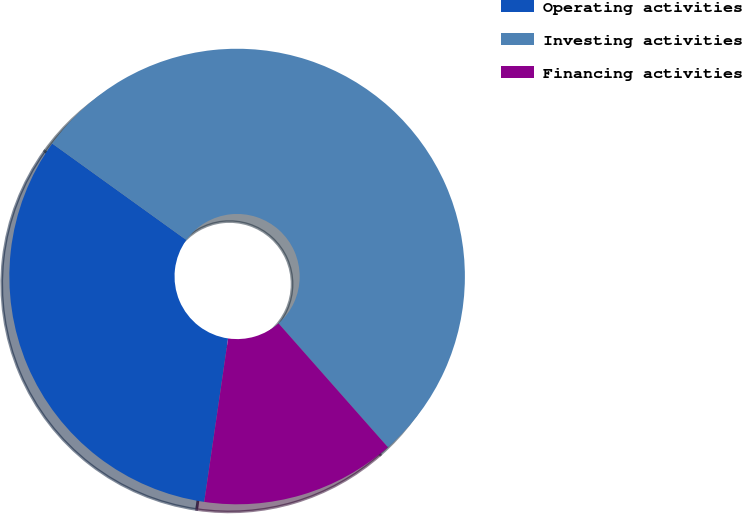Convert chart. <chart><loc_0><loc_0><loc_500><loc_500><pie_chart><fcel>Operating activities<fcel>Investing activities<fcel>Financing activities<nl><fcel>32.62%<fcel>53.56%<fcel>13.82%<nl></chart> 